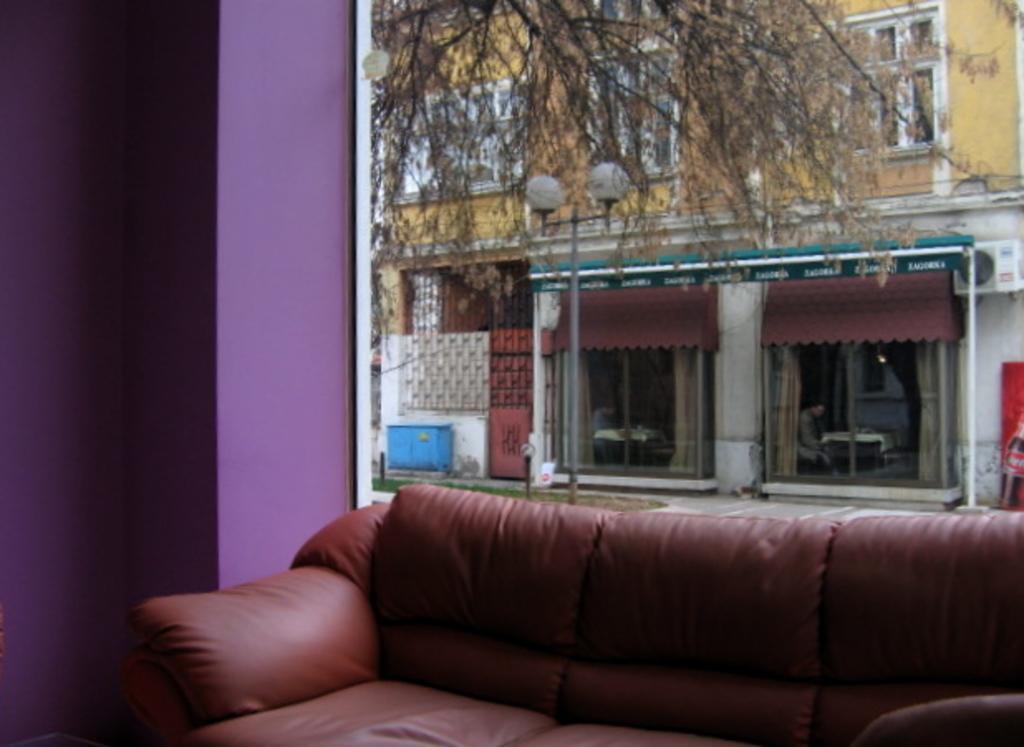Describe this image in one or two sentences. In this picture there is a couch a purple color wall on the left side and trees another building in the background 